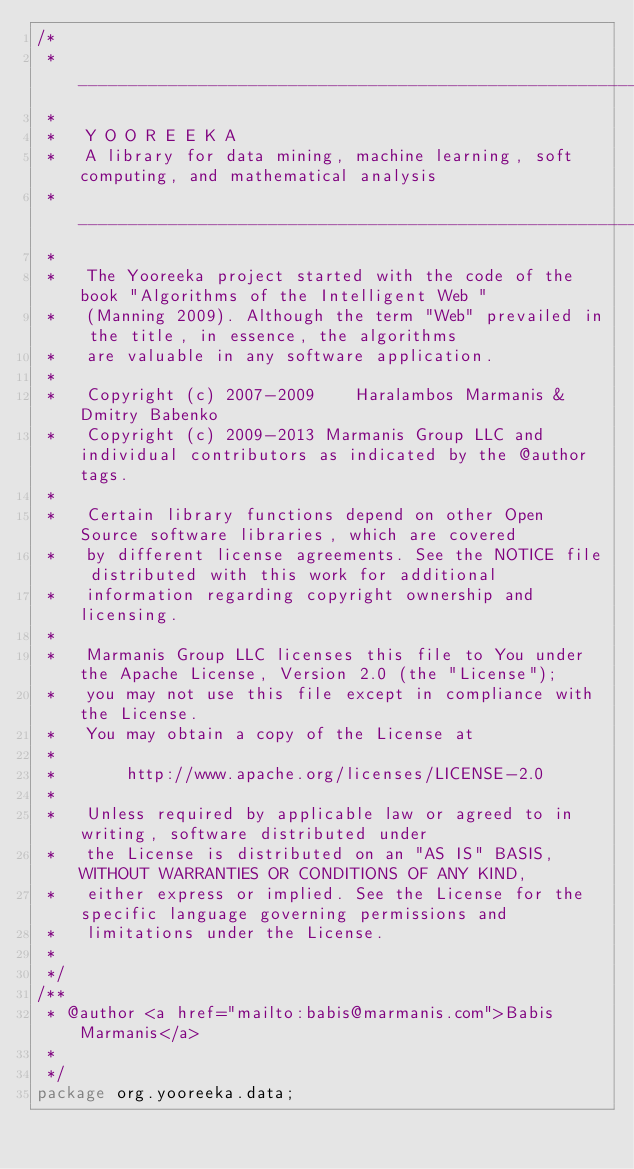<code> <loc_0><loc_0><loc_500><loc_500><_Java_>/*
 *   ________________________________________________________________________________________
 *   
 *   Y O O R E E K A
 *   A library for data mining, machine learning, soft computing, and mathematical analysis
 *   ________________________________________________________________________________________ 
 *    
 *   The Yooreeka project started with the code of the book "Algorithms of the Intelligent Web " 
 *   (Manning 2009). Although the term "Web" prevailed in the title, in essence, the algorithms 
 *   are valuable in any software application.
 *  
 *   Copyright (c) 2007-2009    Haralambos Marmanis & Dmitry Babenko
 *   Copyright (c) 2009-2013 Marmanis Group LLC and individual contributors as indicated by the @author tags.  
 * 
 *   Certain library functions depend on other Open Source software libraries, which are covered 
 *   by different license agreements. See the NOTICE file distributed with this work for additional 
 *   information regarding copyright ownership and licensing.
 * 
 *   Marmanis Group LLC licenses this file to You under the Apache License, Version 2.0 (the "License"); 
 *   you may not use this file except in compliance with the License.  
 *   You may obtain a copy of the License at
 *
 *       http://www.apache.org/licenses/LICENSE-2.0
 *
 *   Unless required by applicable law or agreed to in writing, software distributed under 
 *   the License is distributed on an "AS IS" BASIS, WITHOUT WARRANTIES OR CONDITIONS OF ANY KIND, 
 *   either express or implied. See the License for the specific language governing permissions and
 *   limitations under the License.
 *
 */
/**
 * @author <a href="mailto:babis@marmanis.com">Babis Marmanis</a>
 *
 */
package org.yooreeka.data;</code> 